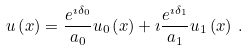Convert formula to latex. <formula><loc_0><loc_0><loc_500><loc_500>u \left ( x \right ) = \frac { e ^ { \imath \delta _ { 0 } } } { a _ { 0 } } u _ { 0 } \left ( x \right ) + \imath \frac { e ^ { \imath \delta _ { 1 } } } { a _ { 1 } } u _ { 1 } \left ( x \right ) \, .</formula> 